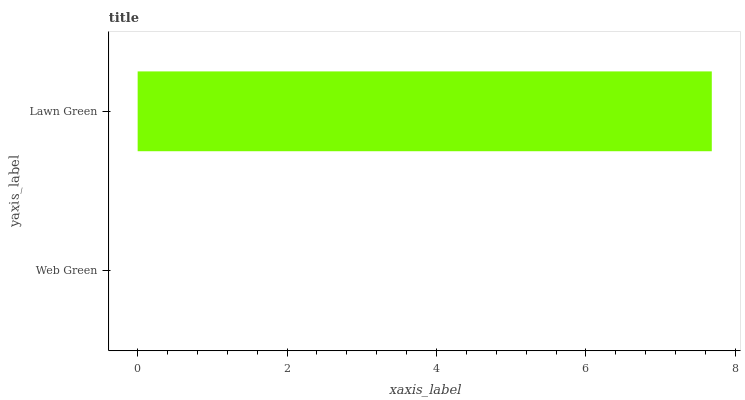Is Web Green the minimum?
Answer yes or no. Yes. Is Lawn Green the maximum?
Answer yes or no. Yes. Is Lawn Green the minimum?
Answer yes or no. No. Is Lawn Green greater than Web Green?
Answer yes or no. Yes. Is Web Green less than Lawn Green?
Answer yes or no. Yes. Is Web Green greater than Lawn Green?
Answer yes or no. No. Is Lawn Green less than Web Green?
Answer yes or no. No. Is Lawn Green the high median?
Answer yes or no. Yes. Is Web Green the low median?
Answer yes or no. Yes. Is Web Green the high median?
Answer yes or no. No. Is Lawn Green the low median?
Answer yes or no. No. 